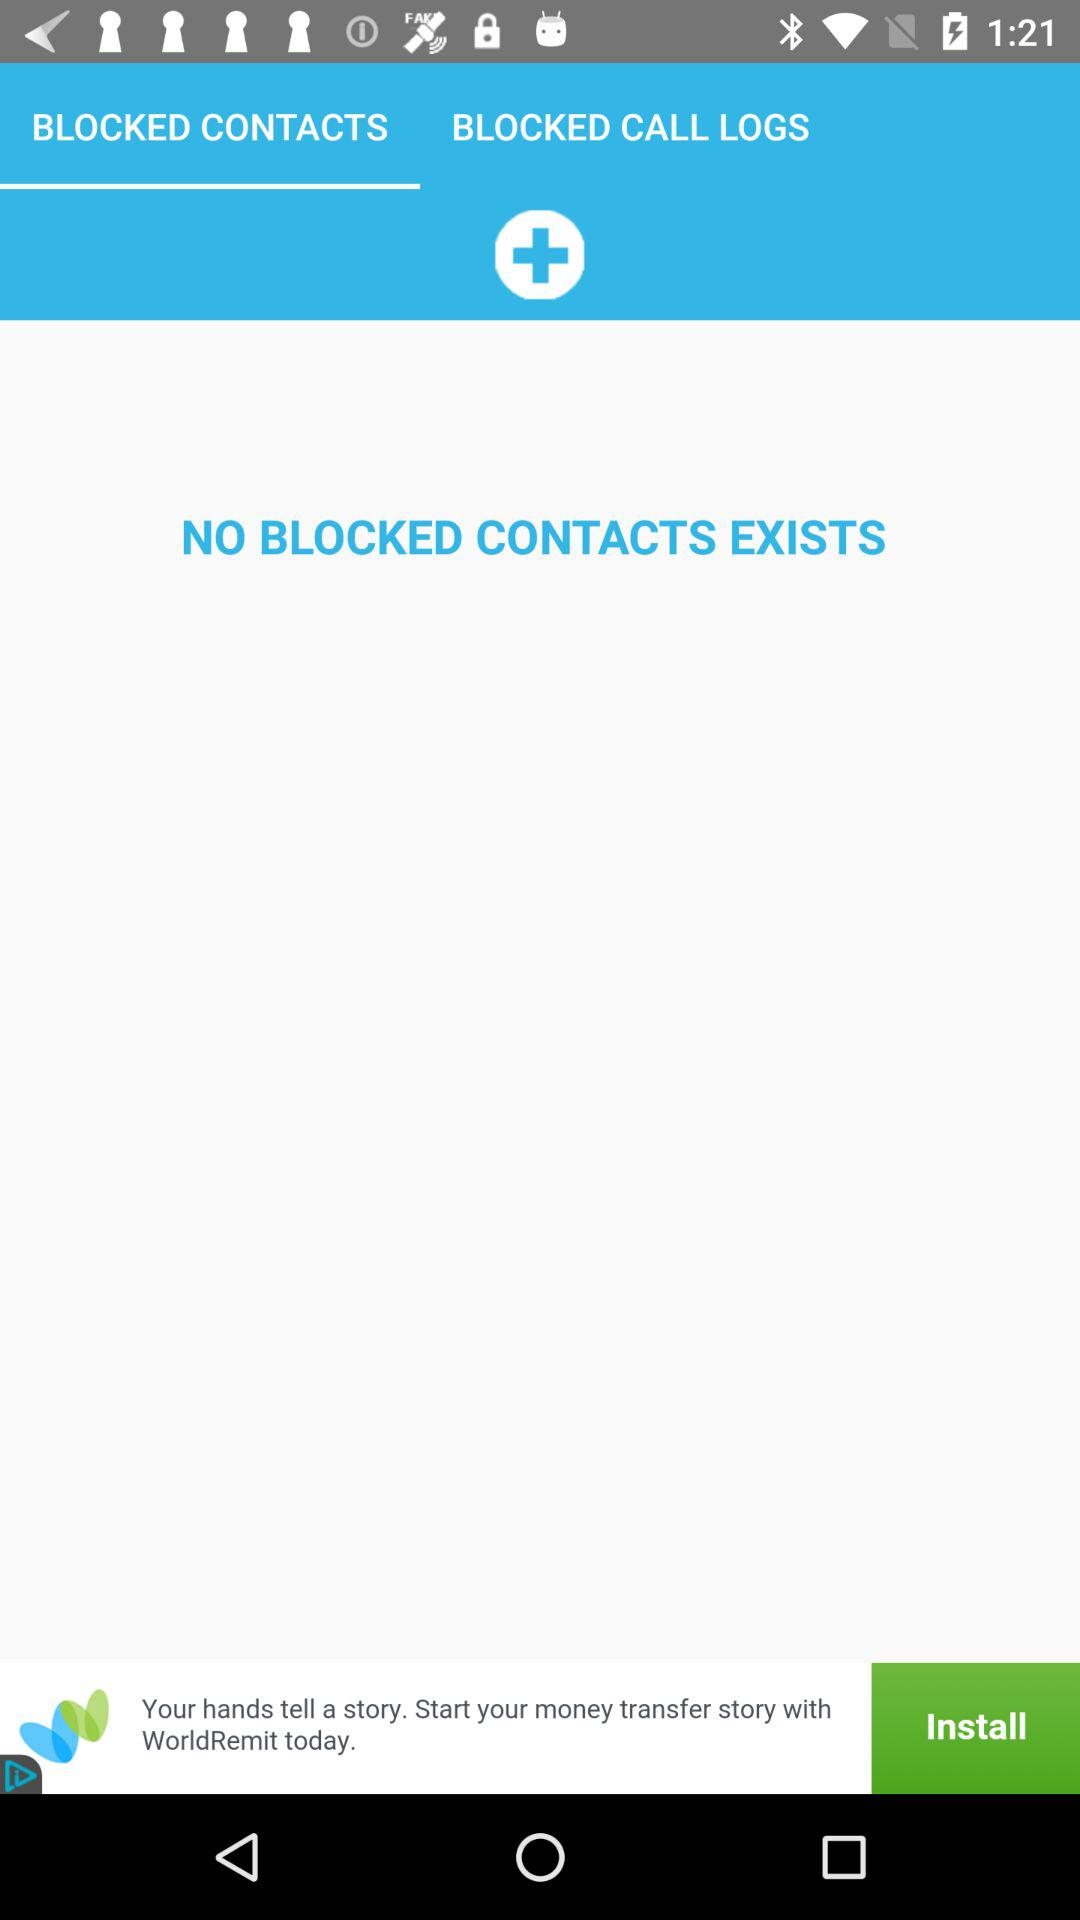Which tab am I on? You are on the "BLOCKED CONTACTS" tab. 